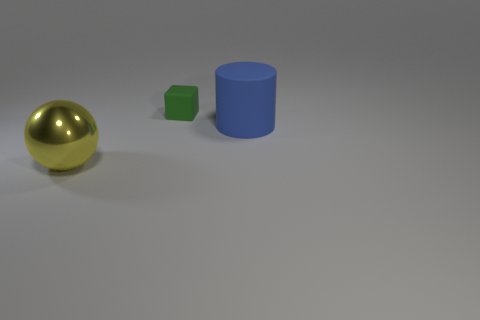Add 1 large shiny objects. How many objects exist? 4 Subtract all cubes. How many objects are left? 2 Subtract 0 gray balls. How many objects are left? 3 Subtract all big gray shiny objects. Subtract all green rubber cubes. How many objects are left? 2 Add 2 cylinders. How many cylinders are left? 3 Add 3 green matte blocks. How many green matte blocks exist? 4 